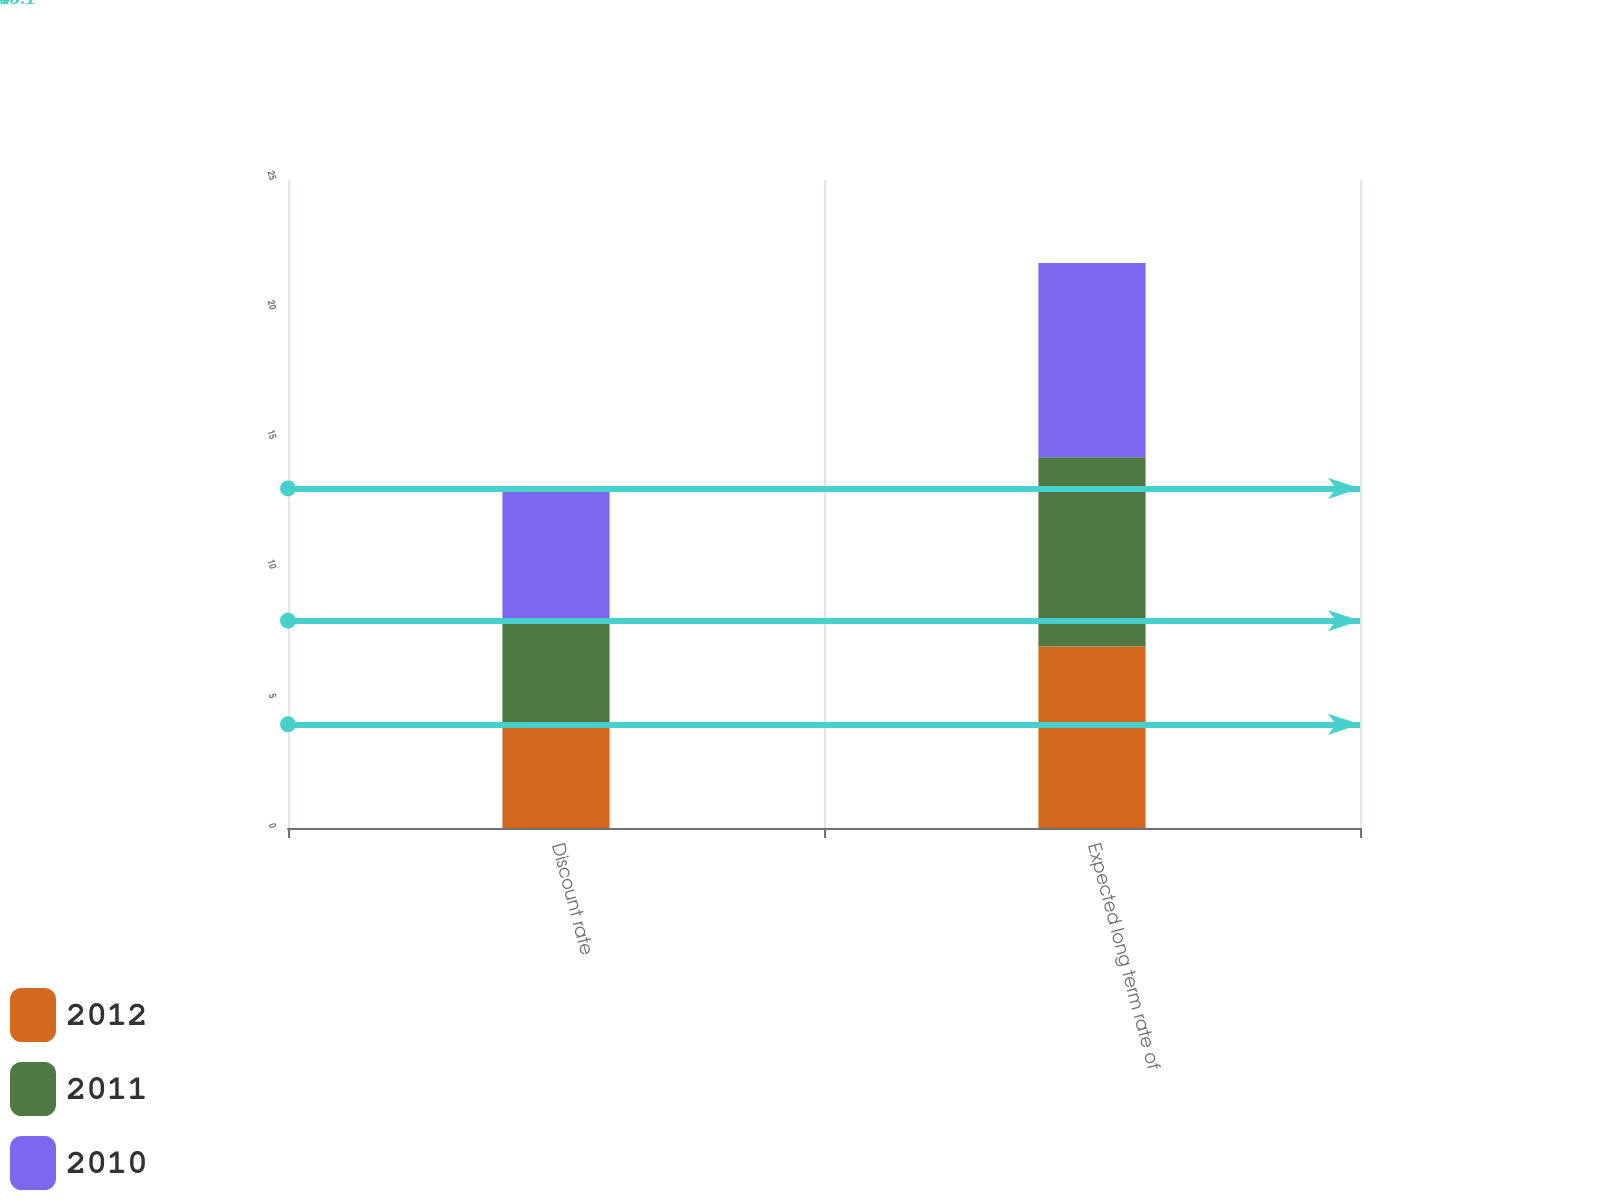<chart> <loc_0><loc_0><loc_500><loc_500><stacked_bar_chart><ecel><fcel>Discount rate<fcel>Expected long term rate of<nl><fcel>2012<fcel>4<fcel>7<nl><fcel>2011<fcel>4<fcel>7.3<nl><fcel>2010<fcel>5.1<fcel>7.5<nl></chart> 